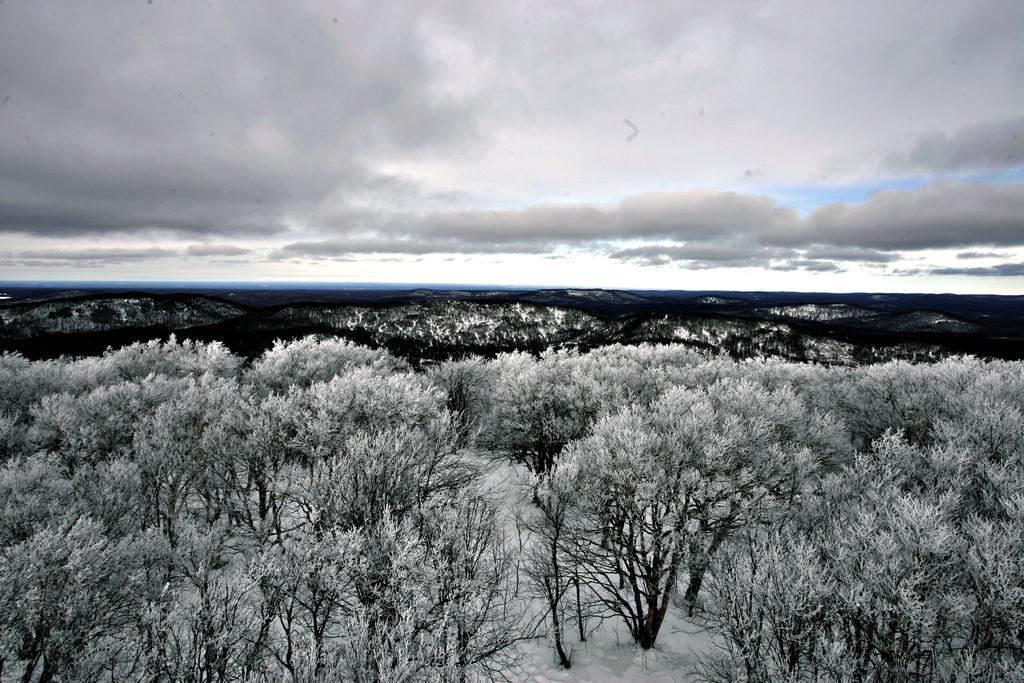Can you describe this image briefly? It looks like an edited image. We can see trees and hills. At the top of the image, there is the cloudy sky. 